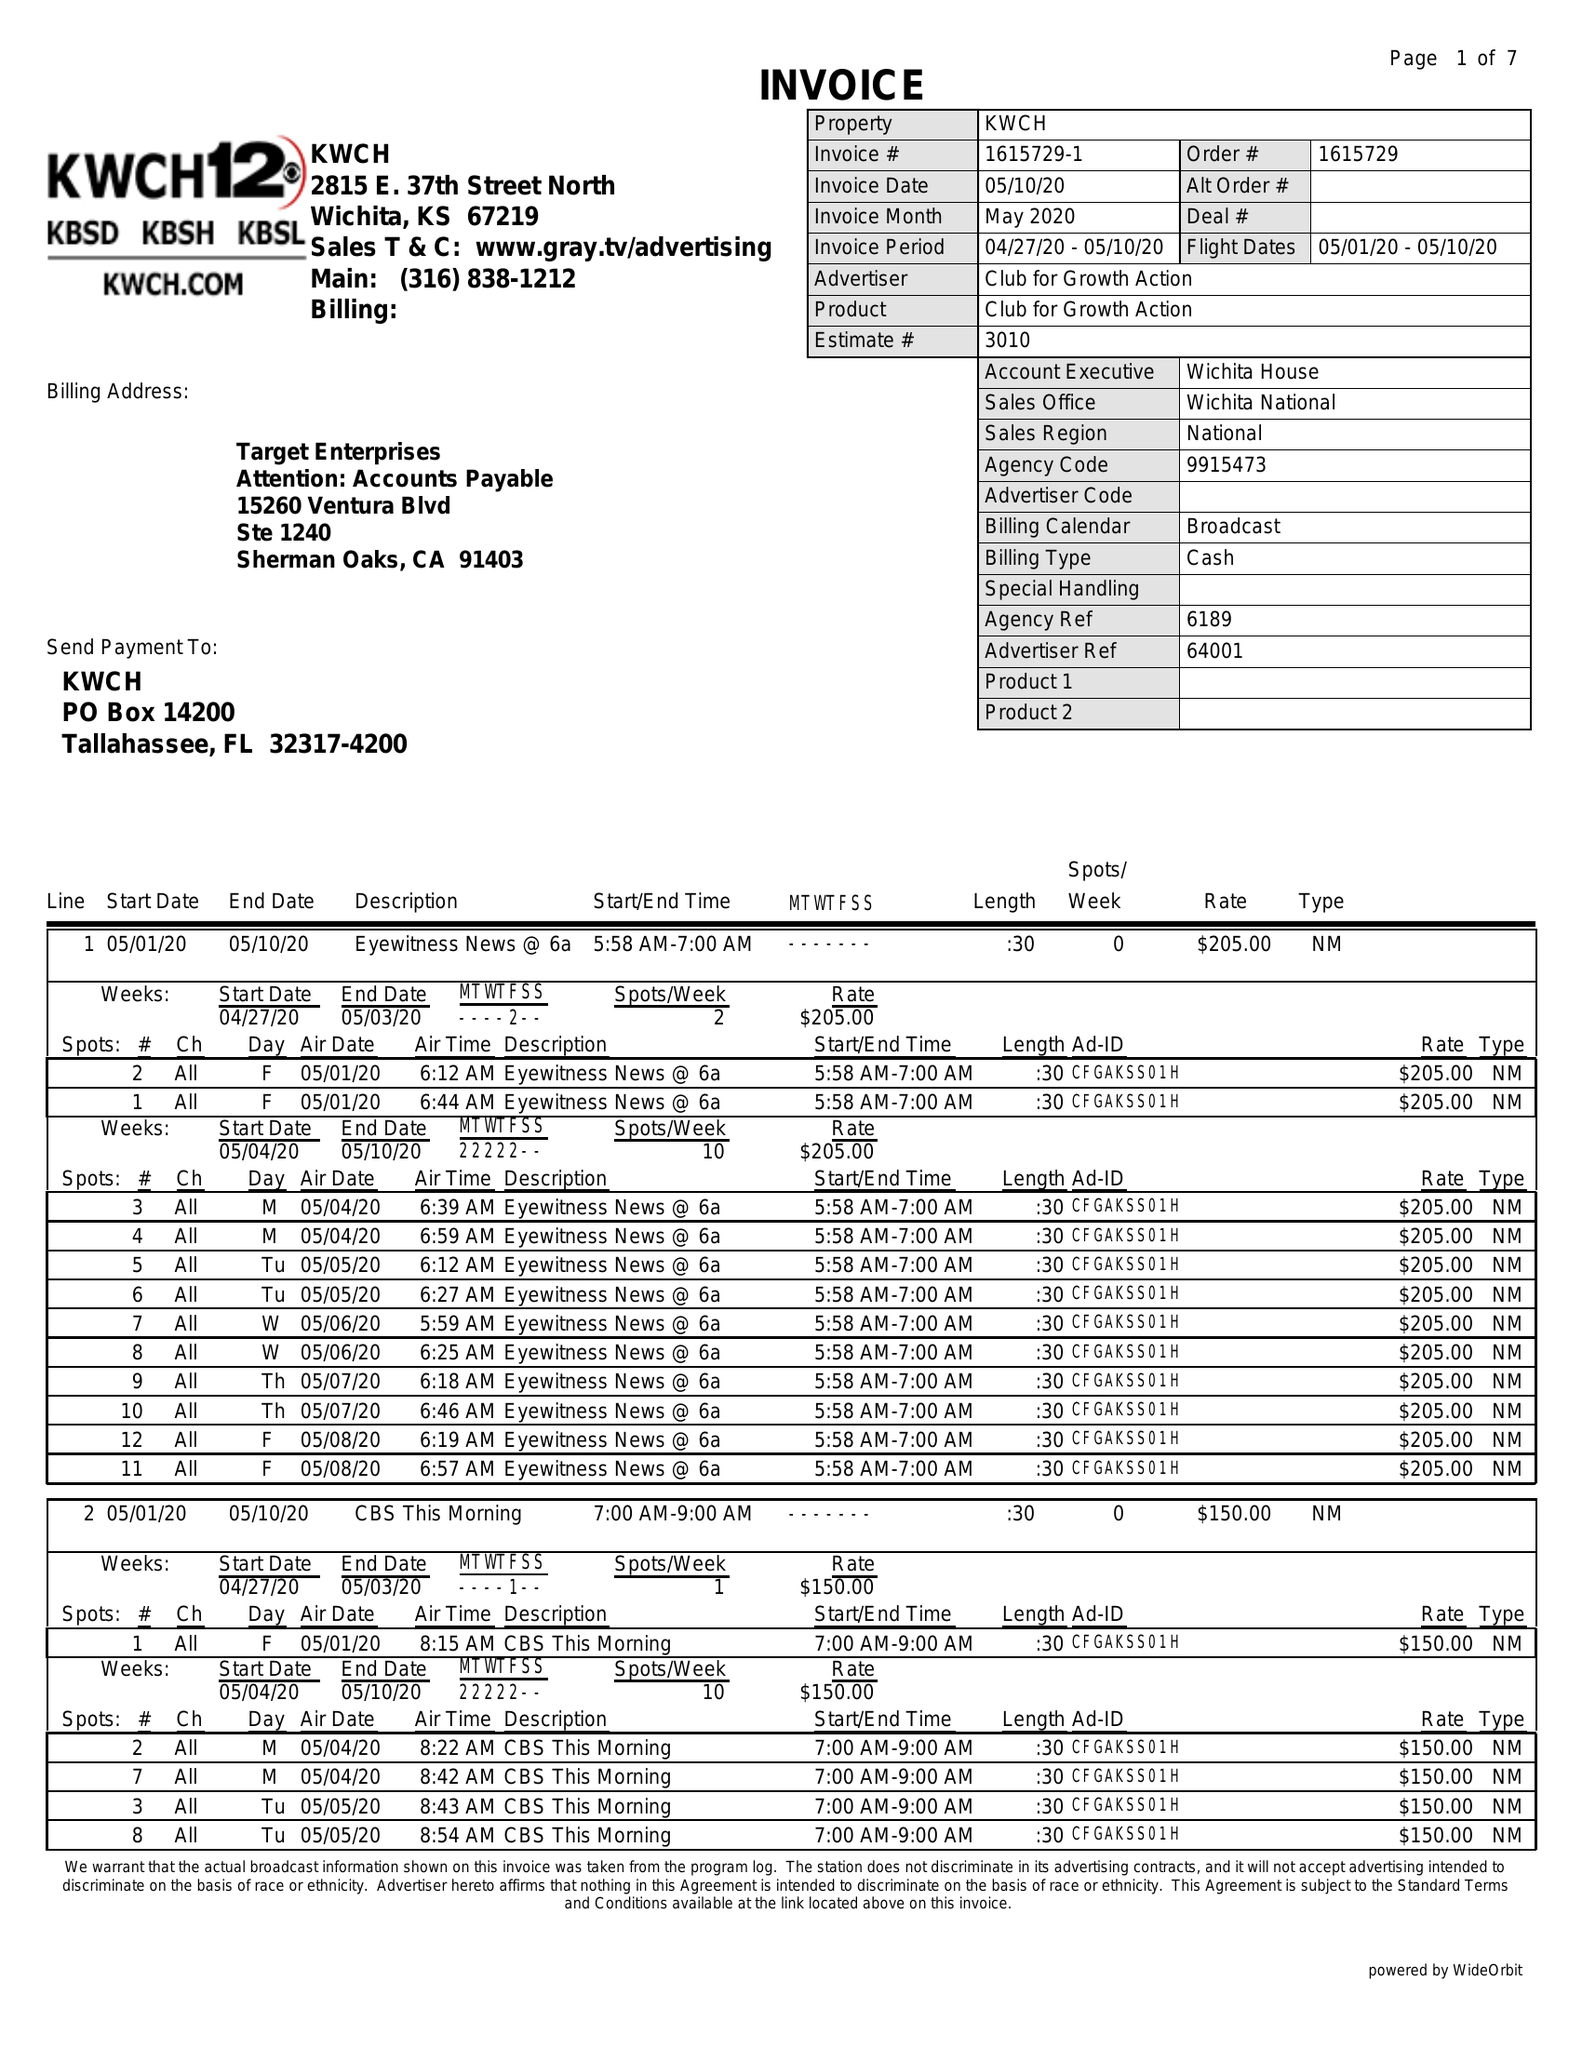What is the value for the contract_num?
Answer the question using a single word or phrase. 1615729 